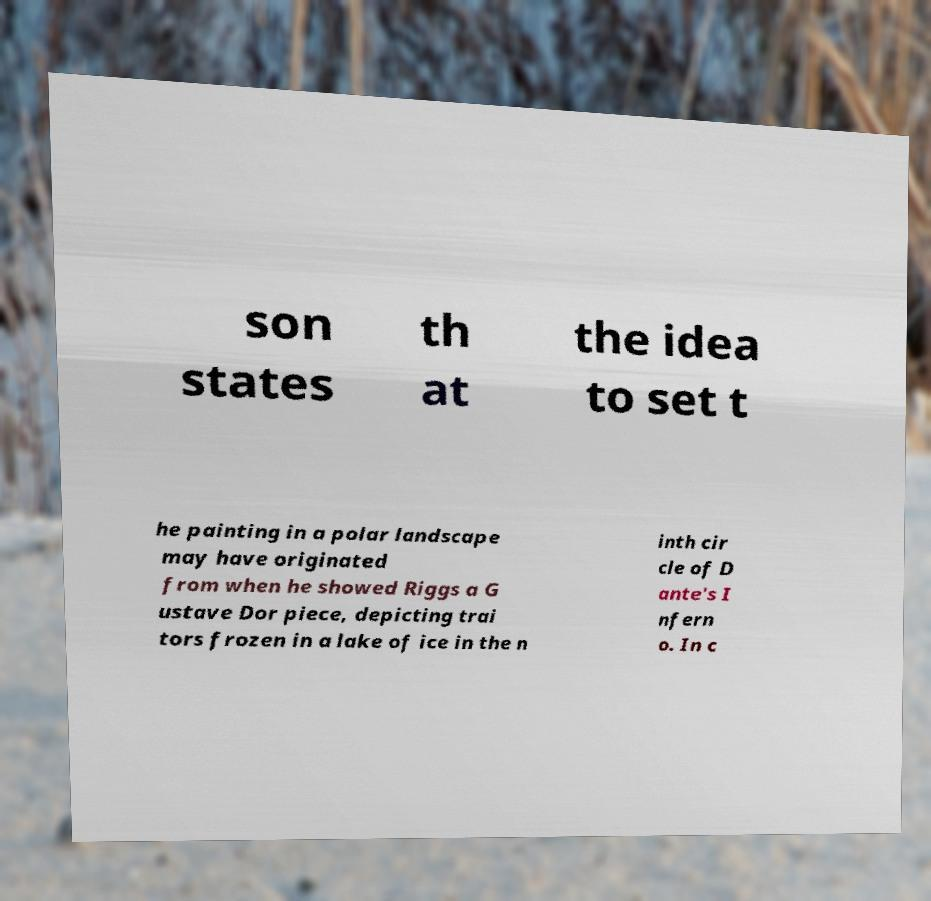Can you accurately transcribe the text from the provided image for me? son states th at the idea to set t he painting in a polar landscape may have originated from when he showed Riggs a G ustave Dor piece, depicting trai tors frozen in a lake of ice in the n inth cir cle of D ante's I nfern o. In c 